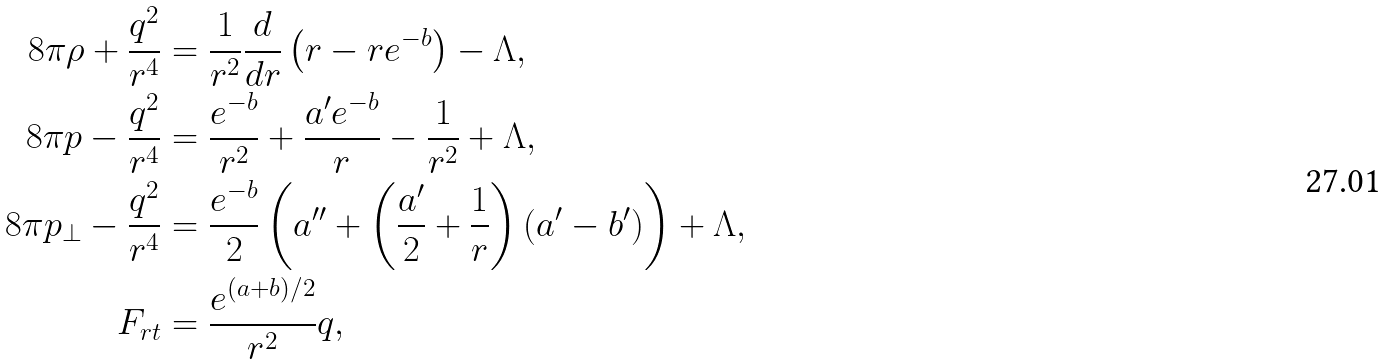<formula> <loc_0><loc_0><loc_500><loc_500>8 \pi \rho + \frac { q ^ { 2 } } { r ^ { 4 } } & = \frac { 1 } { r ^ { 2 } } \frac { d } { d r } \left ( r - r e ^ { - b } \right ) - \Lambda , \\ 8 \pi p - \frac { q ^ { 2 } } { r ^ { 4 } } & = \frac { e ^ { - b } } { r ^ { 2 } } + \frac { a ^ { \prime } e ^ { - b } } { r } - \frac { 1 } { r ^ { 2 } } + \Lambda , \\ 8 \pi p _ { \perp } - \frac { q ^ { 2 } } { r ^ { 4 } } & = \frac { e ^ { - b } } { 2 } \left ( a ^ { \prime \prime } + \left ( \frac { a ^ { \prime } } { 2 } + \frac { 1 } { r } \right ) \left ( a ^ { \prime } - b ^ { \prime } \right ) \right ) + \Lambda , \\ F _ { r t } & = \frac { e ^ { ( a + b ) / 2 } } { r ^ { 2 } } q ,</formula> 